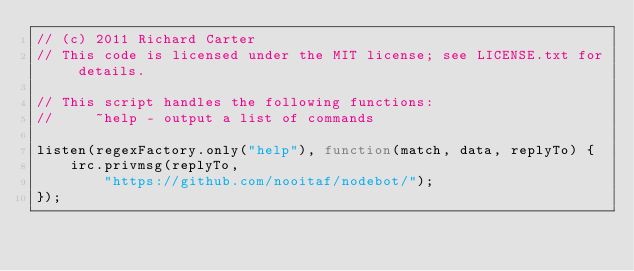Convert code to text. <code><loc_0><loc_0><loc_500><loc_500><_JavaScript_>// (c) 2011 Richard Carter
// This code is licensed under the MIT license; see LICENSE.txt for details.

// This script handles the following functions:
//     ~help - output a list of commands

listen(regexFactory.only("help"), function(match, data, replyTo) {
    irc.privmsg(replyTo,
        "https://github.com/nooitaf/nodebot/");
});
</code> 